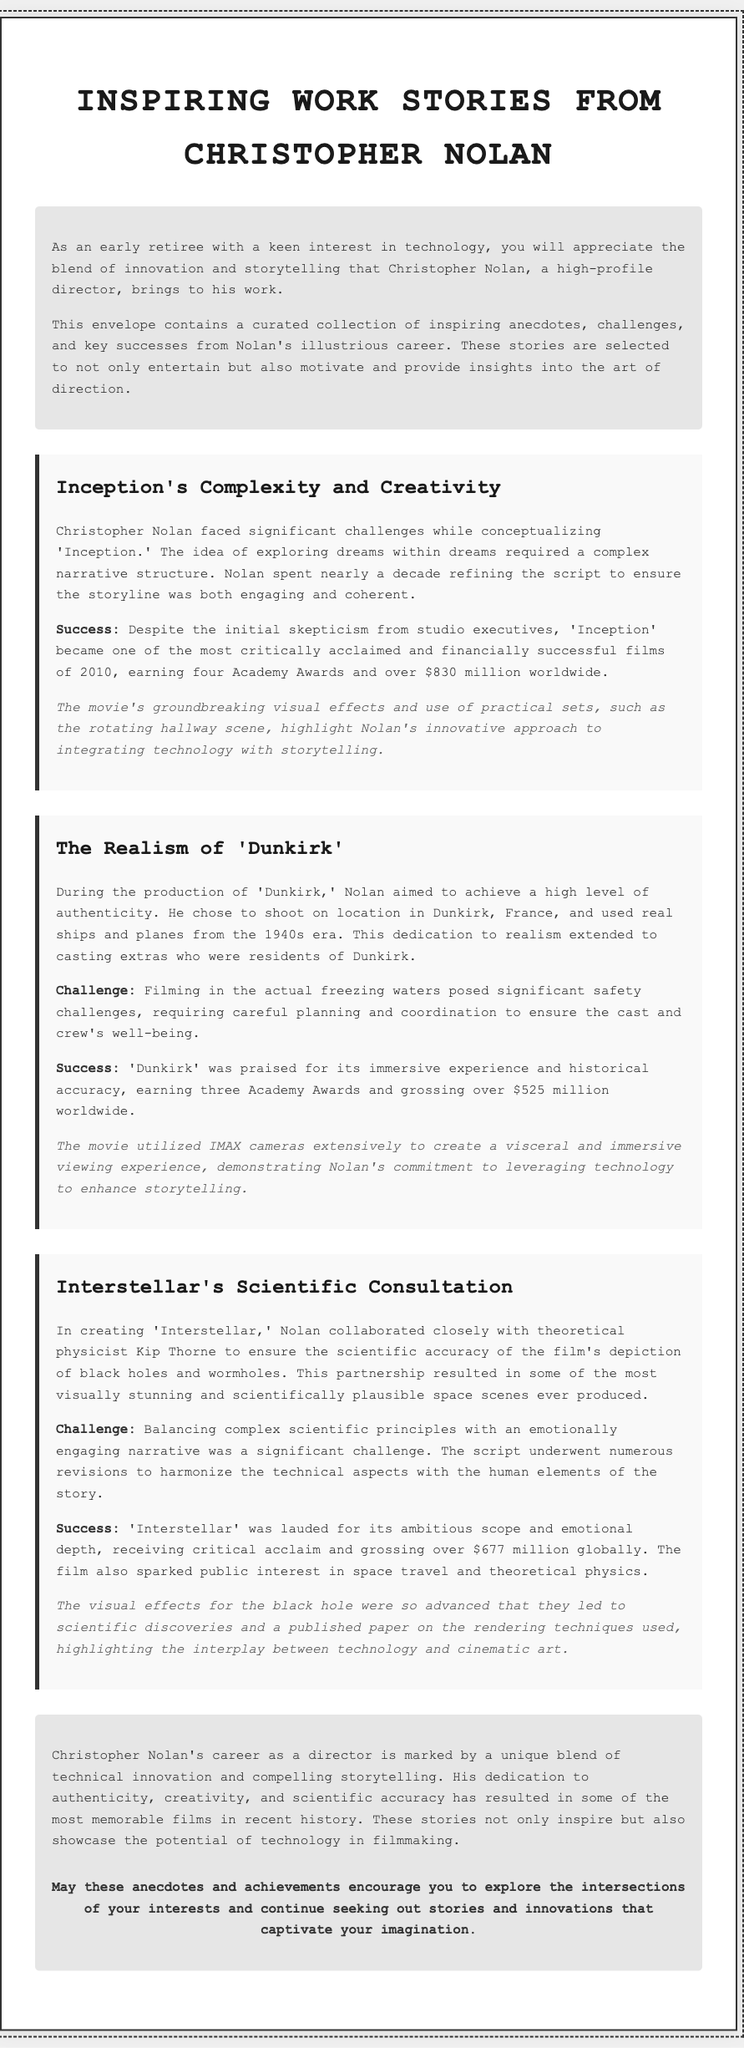What is the title of the document? The title of the document is prominently displayed at the top.
Answer: Inspiring Work Stories from Christopher Nolan How many Academy Awards did 'Inception' earn? The number of Academy Awards is mentioned in the first story of the document.
Answer: Four What was a major challenge Nolan faced with 'Dunkirk'? The document states this challenge in relation to authenticity and safety during shooting.
Answer: Filming in freezing waters Who did Nolan collaborate with for 'Interstellar'? This collaboration is detailed in the third story of the document.
Answer: Kip Thorne How much did 'Dunkirk' gross worldwide? The total gross is specified in the second story of the document.
Answer: Over $525 million What was the primary focus of Nolan's storytelling approach? The document highlights this aspect of his directing style throughout the anecdotes.
Answer: Authenticity What type of cameras did Nolan use in 'Dunkirk'? This specific detail is mentioned in the story about Dunkirk within the document.
Answer: IMAX cameras What does the conclusion emphasize about Nolan's career? The conclusion summarizes the key themes of Nolan's work.
Answer: Technical innovation and compelling storytelling 